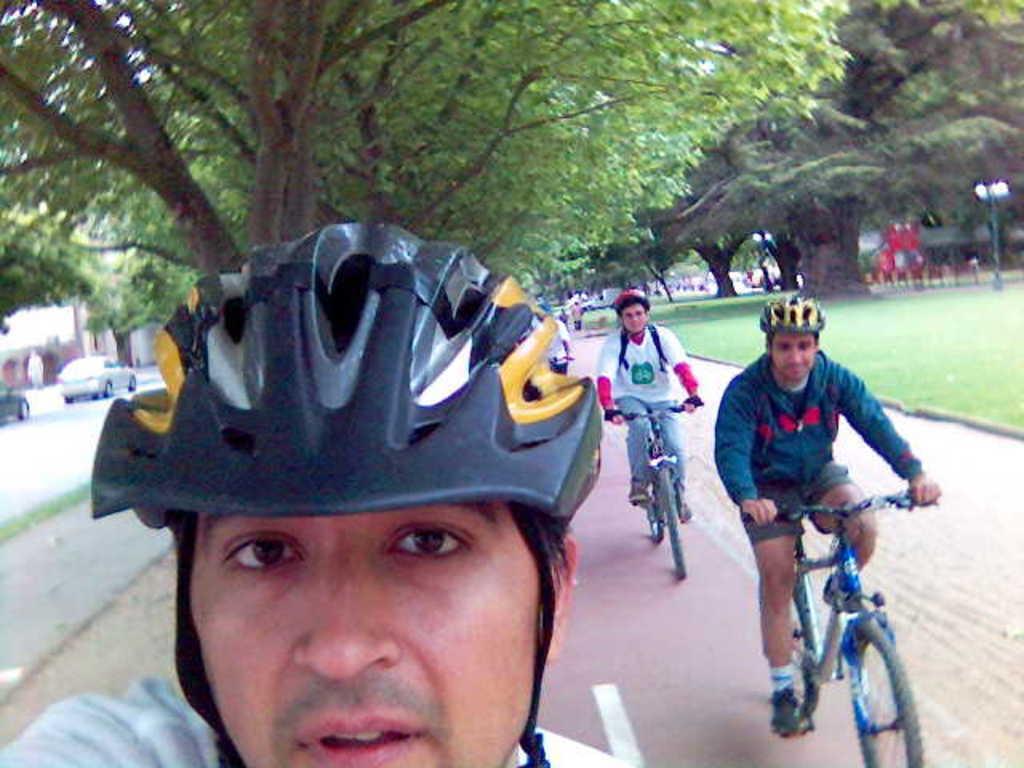How would you summarize this image in a sentence or two? In this picture I can see there are few people riding the bi-cycles and they are wearing helmets and there is grass on right side and there are few cars parked here on the road and there are trees and a pole with a lamp. 